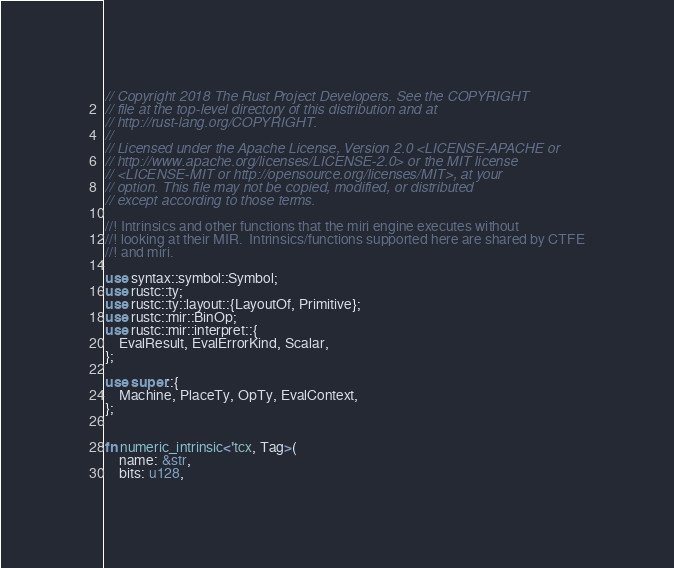<code> <loc_0><loc_0><loc_500><loc_500><_Rust_>// Copyright 2018 The Rust Project Developers. See the COPYRIGHT
// file at the top-level directory of this distribution and at
// http://rust-lang.org/COPYRIGHT.
//
// Licensed under the Apache License, Version 2.0 <LICENSE-APACHE or
// http://www.apache.org/licenses/LICENSE-2.0> or the MIT license
// <LICENSE-MIT or http://opensource.org/licenses/MIT>, at your
// option. This file may not be copied, modified, or distributed
// except according to those terms.

//! Intrinsics and other functions that the miri engine executes without
//! looking at their MIR.  Intrinsics/functions supported here are shared by CTFE
//! and miri.

use syntax::symbol::Symbol;
use rustc::ty;
use rustc::ty::layout::{LayoutOf, Primitive};
use rustc::mir::BinOp;
use rustc::mir::interpret::{
    EvalResult, EvalErrorKind, Scalar,
};

use super::{
    Machine, PlaceTy, OpTy, EvalContext,
};


fn numeric_intrinsic<'tcx, Tag>(
    name: &str,
    bits: u128,</code> 